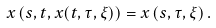Convert formula to latex. <formula><loc_0><loc_0><loc_500><loc_500>x \left ( s , t , x ( t , \tau , \xi ) \right ) = x \left ( s , \tau , \xi \right ) .</formula> 